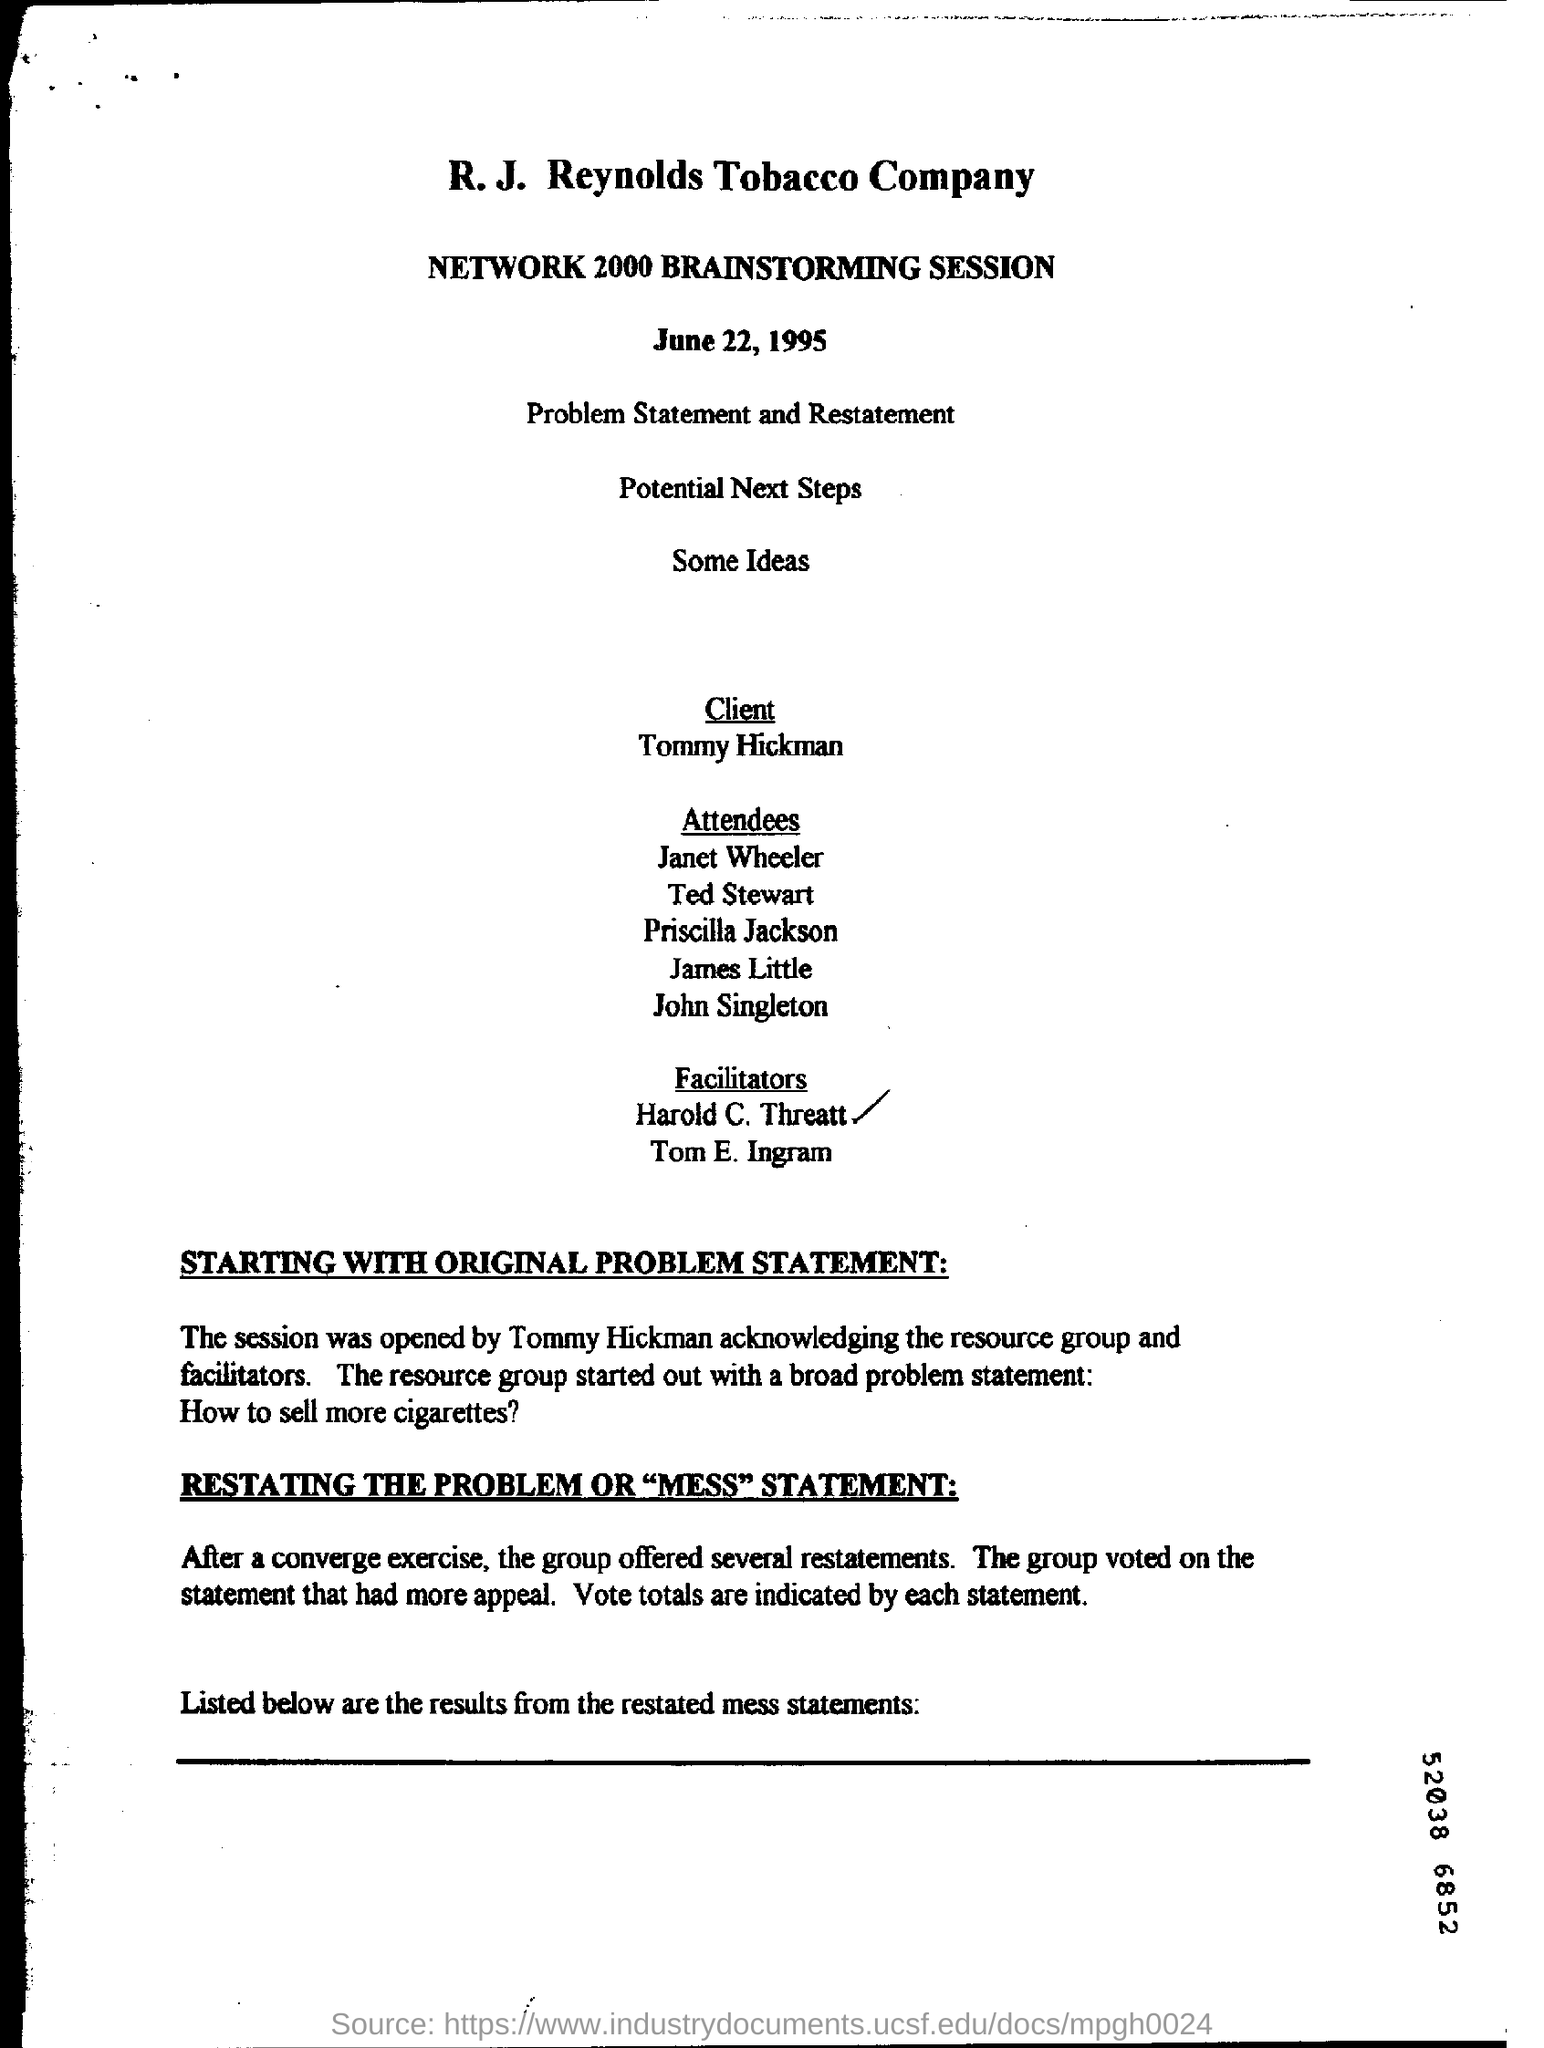Specify some key components in this picture. Tobacco company's client is Tommy Hickman. The name of the session is "Network 2000 Brainstorming. 